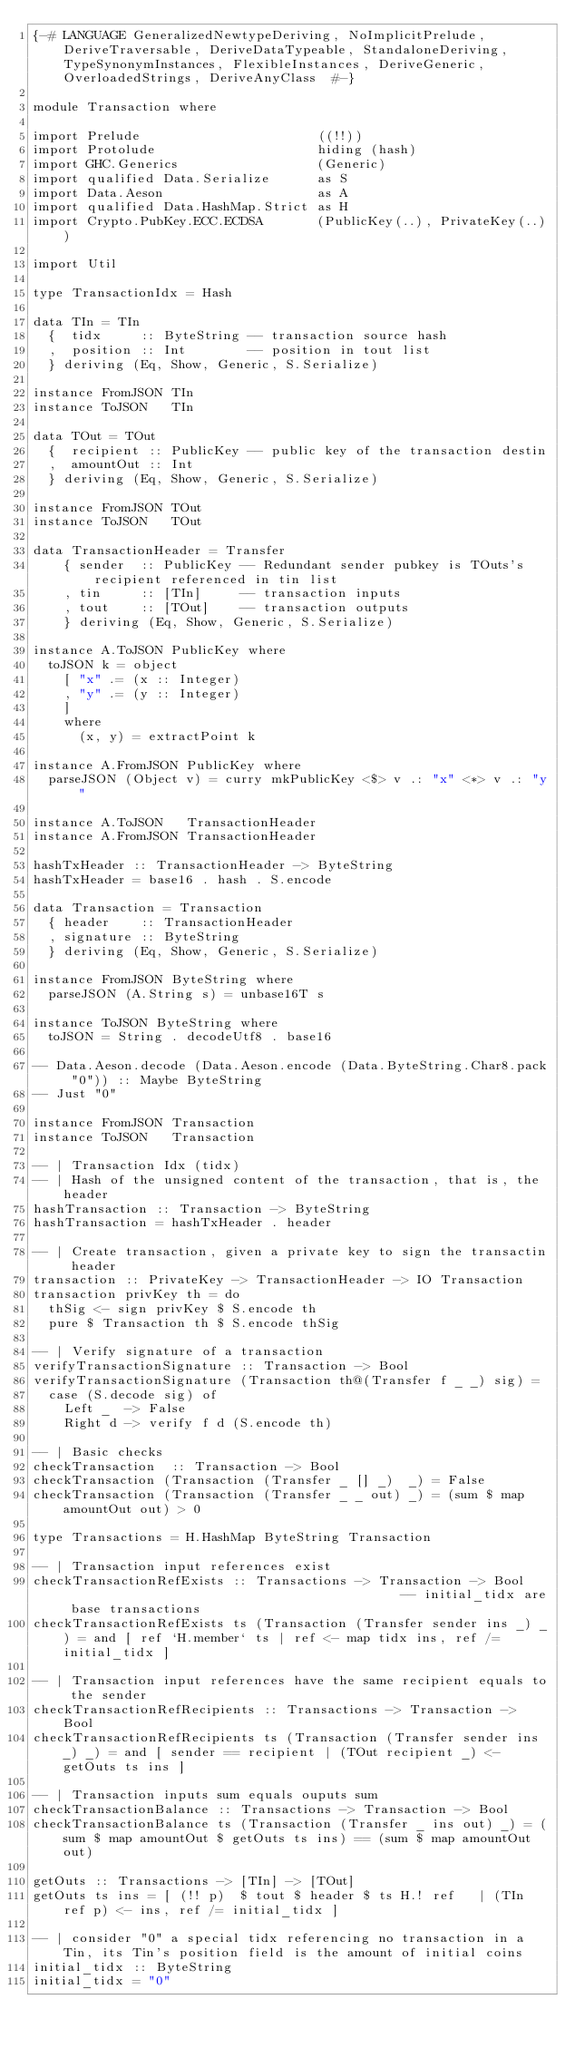<code> <loc_0><loc_0><loc_500><loc_500><_Haskell_>{-# LANGUAGE GeneralizedNewtypeDeriving, NoImplicitPrelude, DeriveTraversable, DeriveDataTypeable, StandaloneDeriving, TypeSynonymInstances, FlexibleInstances, DeriveGeneric, OverloadedStrings, DeriveAnyClass  #-}

module Transaction where

import Prelude                       ((!!))
import Protolude                     hiding (hash)
import GHC.Generics                  (Generic)
import qualified Data.Serialize      as S
import Data.Aeson                    as A
import qualified Data.HashMap.Strict as H
import Crypto.PubKey.ECC.ECDSA       (PublicKey(..), PrivateKey(..))

import Util

type TransactionIdx = Hash

data TIn = TIn
  {  tidx     :: ByteString -- transaction source hash
  ,  position :: Int        -- position in tout list
  } deriving (Eq, Show, Generic, S.Serialize)

instance FromJSON TIn
instance ToJSON   TIn

data TOut = TOut
  {  recipient :: PublicKey -- public key of the transaction destin
  ,  amountOut :: Int       
  } deriving (Eq, Show, Generic, S.Serialize)

instance FromJSON TOut
instance ToJSON   TOut

data TransactionHeader = Transfer
    { sender  :: PublicKey -- Redundant sender pubkey is TOuts's recipient referenced in tin list
    , tin     :: [TIn]     -- transaction inputs
    , tout    :: [TOut]    -- transaction outputs
    } deriving (Eq, Show, Generic, S.Serialize)

instance A.ToJSON PublicKey where
  toJSON k = object
    [ "x" .= (x :: Integer)
    , "y" .= (y :: Integer)
    ]
    where
      (x, y) = extractPoint k

instance A.FromJSON PublicKey where
  parseJSON (Object v) = curry mkPublicKey <$> v .: "x" <*> v .: "y"

instance A.ToJSON   TransactionHeader
instance A.FromJSON TransactionHeader

hashTxHeader :: TransactionHeader -> ByteString
hashTxHeader = base16 . hash . S.encode

data Transaction = Transaction
  { header    :: TransactionHeader
  , signature :: ByteString
  } deriving (Eq, Show, Generic, S.Serialize)

instance FromJSON ByteString where
  parseJSON (A.String s) = unbase16T s

instance ToJSON ByteString where
  toJSON = String . decodeUtf8 . base16  

-- Data.Aeson.decode (Data.Aeson.encode (Data.ByteString.Char8.pack "0")) :: Maybe ByteString
-- Just "0"

instance FromJSON Transaction
instance ToJSON   Transaction

-- | Transaction Idx (tidx)
-- | Hash of the unsigned content of the transaction, that is, the header
hashTransaction :: Transaction -> ByteString
hashTransaction = hashTxHeader . header

-- | Create transaction, given a private key to sign the transactin header
transaction :: PrivateKey -> TransactionHeader -> IO Transaction
transaction privKey th = do
  thSig <- sign privKey $ S.encode th
  pure $ Transaction th $ S.encode thSig

-- | Verify signature of a transaction
verifyTransactionSignature :: Transaction -> Bool
verifyTransactionSignature (Transaction th@(Transfer f _ _) sig) =
  case (S.decode sig) of
    Left _  -> False
    Right d -> verify f d (S.encode th)

-- | Basic checks
checkTransaction  :: Transaction -> Bool
checkTransaction (Transaction (Transfer _ [] _)  _) = False
checkTransaction (Transaction (Transfer _ _ out) _) = (sum $ map amountOut out) > 0

type Transactions = H.HashMap ByteString Transaction

-- | Transaction input references exist
checkTransactionRefExists :: Transactions -> Transaction -> Bool                                             -- initial_tidx are base transactions
checkTransactionRefExists ts (Transaction (Transfer sender ins _) _) = and [ ref `H.member` ts | ref <- map tidx ins, ref /= initial_tidx ]

-- | Transaction input references have the same recipient equals to the sender
checkTransactionRefRecipients :: Transactions -> Transaction -> Bool
checkTransactionRefRecipients ts (Transaction (Transfer sender ins _) _) = and [ sender == recipient | (TOut recipient _) <- getOuts ts ins ]

-- | Transaction inputs sum equals ouputs sum
checkTransactionBalance :: Transactions -> Transaction -> Bool
checkTransactionBalance ts (Transaction (Transfer _ ins out) _) = (sum $ map amountOut $ getOuts ts ins) == (sum $ map amountOut out)

getOuts :: Transactions -> [TIn] -> [TOut]
getOuts ts ins = [ (!! p)  $ tout $ header $ ts H.! ref   | (TIn ref p) <- ins, ref /= initial_tidx ]

-- | consider "0" a special tidx referencing no transaction in a Tin, its Tin's position field is the amount of initial coins
initial_tidx :: ByteString
initial_tidx = "0"
</code> 